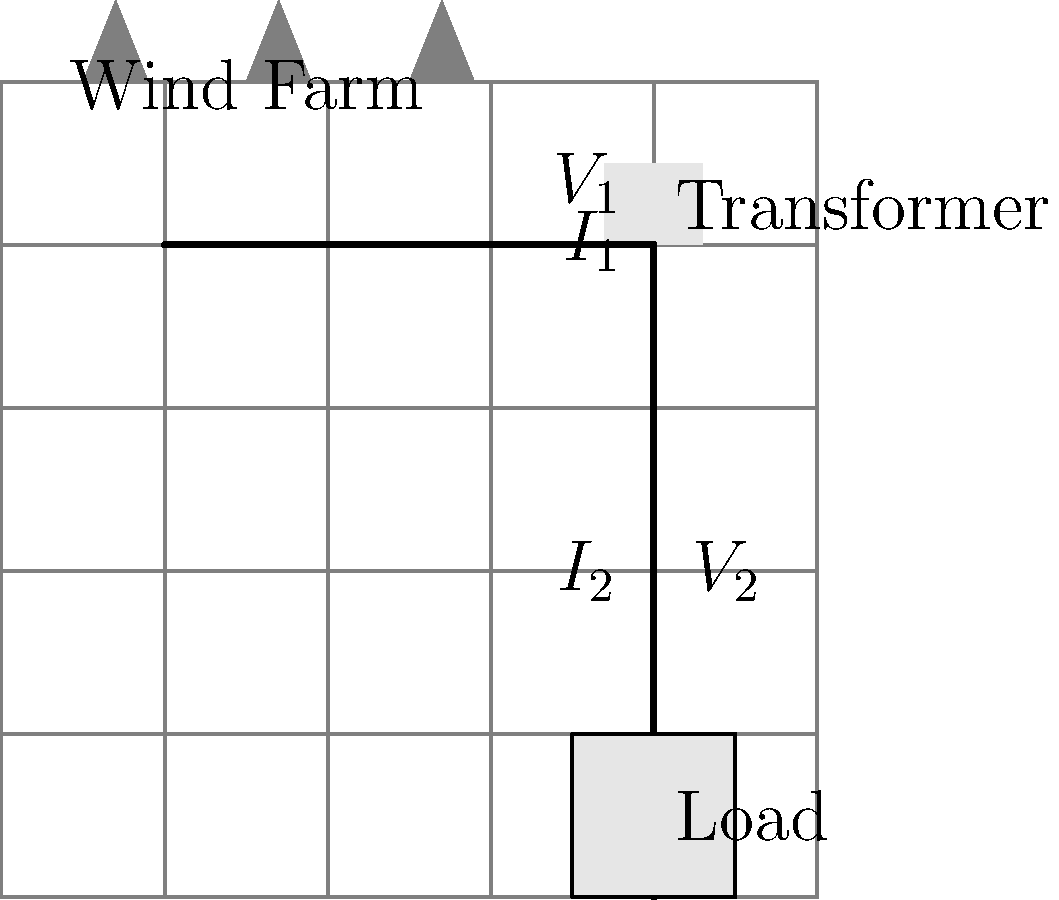In the wind farm power transmission system shown, the transformer steps up the voltage from $V_1$ to $V_2$. If the power input at the wind farm is 100 MW and the transmission efficiency is 98%, what is the current $I_2$ in the transmission line if $V_2$ is 500 kV? To solve this problem, we'll follow these steps:

1. Calculate the power output after transmission losses:
   Power output = Power input × Efficiency
   $P_{out} = 100 \text{ MW} \times 0.98 = 98 \text{ MW}$

2. Convert MW to W:
   $98 \text{ MW} = 98 \times 10^6 \text{ W}$

3. Use the power equation for AC systems:
   $P = \sqrt{3} \times V \times I \times \cos\phi$
   
   Where:
   $P$ is power in watts
   $V$ is line-to-line voltage
   $I$ is line current
   $\cos\phi$ is the power factor (assume 1 for simplicity)

4. Rearrange the equation to solve for current:
   $I = \frac{P}{\sqrt{3} \times V}$

5. Plug in the values:
   $I_2 = \frac{98 \times 10^6}{\sqrt{3} \times 500 \times 10^3}$

6. Calculate the result:
   $I_2 = \frac{98 \times 10^6}{866,025} \approx 113.16 \text{ A}$

Therefore, the current $I_2$ in the transmission line is approximately 113.16 A.
Answer: 113.16 A 